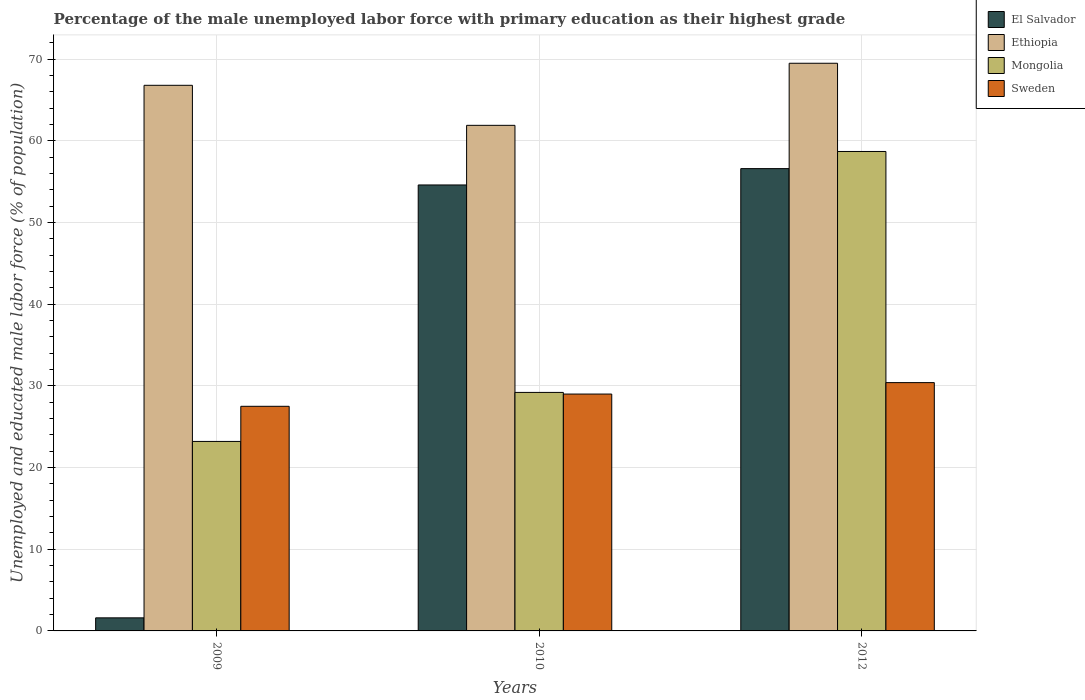How many different coloured bars are there?
Offer a very short reply. 4. Are the number of bars on each tick of the X-axis equal?
Your response must be concise. Yes. How many bars are there on the 1st tick from the left?
Offer a very short reply. 4. What is the label of the 1st group of bars from the left?
Provide a short and direct response. 2009. What is the percentage of the unemployed male labor force with primary education in El Salvador in 2010?
Give a very brief answer. 54.6. Across all years, what is the maximum percentage of the unemployed male labor force with primary education in Mongolia?
Give a very brief answer. 58.7. Across all years, what is the minimum percentage of the unemployed male labor force with primary education in Mongolia?
Provide a short and direct response. 23.2. In which year was the percentage of the unemployed male labor force with primary education in Ethiopia maximum?
Your response must be concise. 2012. In which year was the percentage of the unemployed male labor force with primary education in El Salvador minimum?
Your answer should be very brief. 2009. What is the total percentage of the unemployed male labor force with primary education in Sweden in the graph?
Ensure brevity in your answer.  86.9. What is the difference between the percentage of the unemployed male labor force with primary education in Sweden in 2010 and the percentage of the unemployed male labor force with primary education in El Salvador in 2009?
Your answer should be compact. 27.4. What is the average percentage of the unemployed male labor force with primary education in Ethiopia per year?
Your answer should be compact. 66.07. In the year 2010, what is the difference between the percentage of the unemployed male labor force with primary education in Mongolia and percentage of the unemployed male labor force with primary education in Sweden?
Provide a succinct answer. 0.2. What is the ratio of the percentage of the unemployed male labor force with primary education in Ethiopia in 2010 to that in 2012?
Your answer should be compact. 0.89. Is the percentage of the unemployed male labor force with primary education in Sweden in 2010 less than that in 2012?
Provide a short and direct response. Yes. Is the difference between the percentage of the unemployed male labor force with primary education in Mongolia in 2009 and 2012 greater than the difference between the percentage of the unemployed male labor force with primary education in Sweden in 2009 and 2012?
Your answer should be very brief. No. What is the difference between the highest and the second highest percentage of the unemployed male labor force with primary education in Mongolia?
Ensure brevity in your answer.  29.5. What is the difference between the highest and the lowest percentage of the unemployed male labor force with primary education in Mongolia?
Ensure brevity in your answer.  35.5. In how many years, is the percentage of the unemployed male labor force with primary education in Mongolia greater than the average percentage of the unemployed male labor force with primary education in Mongolia taken over all years?
Provide a succinct answer. 1. What does the 2nd bar from the left in 2010 represents?
Ensure brevity in your answer.  Ethiopia. What does the 2nd bar from the right in 2012 represents?
Provide a short and direct response. Mongolia. Is it the case that in every year, the sum of the percentage of the unemployed male labor force with primary education in Mongolia and percentage of the unemployed male labor force with primary education in El Salvador is greater than the percentage of the unemployed male labor force with primary education in Ethiopia?
Offer a very short reply. No. How many years are there in the graph?
Your answer should be compact. 3. What is the difference between two consecutive major ticks on the Y-axis?
Make the answer very short. 10. Are the values on the major ticks of Y-axis written in scientific E-notation?
Offer a very short reply. No. How are the legend labels stacked?
Ensure brevity in your answer.  Vertical. What is the title of the graph?
Make the answer very short. Percentage of the male unemployed labor force with primary education as their highest grade. Does "Luxembourg" appear as one of the legend labels in the graph?
Provide a short and direct response. No. What is the label or title of the X-axis?
Offer a terse response. Years. What is the label or title of the Y-axis?
Provide a succinct answer. Unemployed and educated male labor force (% of population). What is the Unemployed and educated male labor force (% of population) in El Salvador in 2009?
Your answer should be very brief. 1.6. What is the Unemployed and educated male labor force (% of population) of Ethiopia in 2009?
Ensure brevity in your answer.  66.8. What is the Unemployed and educated male labor force (% of population) in Mongolia in 2009?
Your answer should be compact. 23.2. What is the Unemployed and educated male labor force (% of population) in Sweden in 2009?
Give a very brief answer. 27.5. What is the Unemployed and educated male labor force (% of population) of El Salvador in 2010?
Provide a short and direct response. 54.6. What is the Unemployed and educated male labor force (% of population) in Ethiopia in 2010?
Provide a short and direct response. 61.9. What is the Unemployed and educated male labor force (% of population) in Mongolia in 2010?
Your response must be concise. 29.2. What is the Unemployed and educated male labor force (% of population) in El Salvador in 2012?
Provide a succinct answer. 56.6. What is the Unemployed and educated male labor force (% of population) of Ethiopia in 2012?
Give a very brief answer. 69.5. What is the Unemployed and educated male labor force (% of population) of Mongolia in 2012?
Your answer should be very brief. 58.7. What is the Unemployed and educated male labor force (% of population) in Sweden in 2012?
Your answer should be compact. 30.4. Across all years, what is the maximum Unemployed and educated male labor force (% of population) of El Salvador?
Make the answer very short. 56.6. Across all years, what is the maximum Unemployed and educated male labor force (% of population) of Ethiopia?
Provide a short and direct response. 69.5. Across all years, what is the maximum Unemployed and educated male labor force (% of population) of Mongolia?
Provide a succinct answer. 58.7. Across all years, what is the maximum Unemployed and educated male labor force (% of population) in Sweden?
Provide a short and direct response. 30.4. Across all years, what is the minimum Unemployed and educated male labor force (% of population) of El Salvador?
Your answer should be very brief. 1.6. Across all years, what is the minimum Unemployed and educated male labor force (% of population) in Ethiopia?
Keep it short and to the point. 61.9. Across all years, what is the minimum Unemployed and educated male labor force (% of population) of Mongolia?
Provide a succinct answer. 23.2. Across all years, what is the minimum Unemployed and educated male labor force (% of population) of Sweden?
Your response must be concise. 27.5. What is the total Unemployed and educated male labor force (% of population) of El Salvador in the graph?
Offer a terse response. 112.8. What is the total Unemployed and educated male labor force (% of population) in Ethiopia in the graph?
Provide a succinct answer. 198.2. What is the total Unemployed and educated male labor force (% of population) of Mongolia in the graph?
Your response must be concise. 111.1. What is the total Unemployed and educated male labor force (% of population) in Sweden in the graph?
Provide a short and direct response. 86.9. What is the difference between the Unemployed and educated male labor force (% of population) of El Salvador in 2009 and that in 2010?
Give a very brief answer. -53. What is the difference between the Unemployed and educated male labor force (% of population) of Sweden in 2009 and that in 2010?
Your answer should be very brief. -1.5. What is the difference between the Unemployed and educated male labor force (% of population) of El Salvador in 2009 and that in 2012?
Offer a very short reply. -55. What is the difference between the Unemployed and educated male labor force (% of population) of Ethiopia in 2009 and that in 2012?
Your answer should be compact. -2.7. What is the difference between the Unemployed and educated male labor force (% of population) of Mongolia in 2009 and that in 2012?
Provide a succinct answer. -35.5. What is the difference between the Unemployed and educated male labor force (% of population) in Ethiopia in 2010 and that in 2012?
Provide a short and direct response. -7.6. What is the difference between the Unemployed and educated male labor force (% of population) in Mongolia in 2010 and that in 2012?
Offer a very short reply. -29.5. What is the difference between the Unemployed and educated male labor force (% of population) of Sweden in 2010 and that in 2012?
Provide a succinct answer. -1.4. What is the difference between the Unemployed and educated male labor force (% of population) of El Salvador in 2009 and the Unemployed and educated male labor force (% of population) of Ethiopia in 2010?
Give a very brief answer. -60.3. What is the difference between the Unemployed and educated male labor force (% of population) of El Salvador in 2009 and the Unemployed and educated male labor force (% of population) of Mongolia in 2010?
Offer a terse response. -27.6. What is the difference between the Unemployed and educated male labor force (% of population) of El Salvador in 2009 and the Unemployed and educated male labor force (% of population) of Sweden in 2010?
Offer a terse response. -27.4. What is the difference between the Unemployed and educated male labor force (% of population) in Ethiopia in 2009 and the Unemployed and educated male labor force (% of population) in Mongolia in 2010?
Offer a very short reply. 37.6. What is the difference between the Unemployed and educated male labor force (% of population) of Ethiopia in 2009 and the Unemployed and educated male labor force (% of population) of Sweden in 2010?
Give a very brief answer. 37.8. What is the difference between the Unemployed and educated male labor force (% of population) of Mongolia in 2009 and the Unemployed and educated male labor force (% of population) of Sweden in 2010?
Provide a succinct answer. -5.8. What is the difference between the Unemployed and educated male labor force (% of population) in El Salvador in 2009 and the Unemployed and educated male labor force (% of population) in Ethiopia in 2012?
Make the answer very short. -67.9. What is the difference between the Unemployed and educated male labor force (% of population) of El Salvador in 2009 and the Unemployed and educated male labor force (% of population) of Mongolia in 2012?
Your answer should be very brief. -57.1. What is the difference between the Unemployed and educated male labor force (% of population) in El Salvador in 2009 and the Unemployed and educated male labor force (% of population) in Sweden in 2012?
Offer a very short reply. -28.8. What is the difference between the Unemployed and educated male labor force (% of population) in Ethiopia in 2009 and the Unemployed and educated male labor force (% of population) in Sweden in 2012?
Your answer should be compact. 36.4. What is the difference between the Unemployed and educated male labor force (% of population) of El Salvador in 2010 and the Unemployed and educated male labor force (% of population) of Ethiopia in 2012?
Your response must be concise. -14.9. What is the difference between the Unemployed and educated male labor force (% of population) in El Salvador in 2010 and the Unemployed and educated male labor force (% of population) in Mongolia in 2012?
Your answer should be very brief. -4.1. What is the difference between the Unemployed and educated male labor force (% of population) of El Salvador in 2010 and the Unemployed and educated male labor force (% of population) of Sweden in 2012?
Offer a terse response. 24.2. What is the difference between the Unemployed and educated male labor force (% of population) in Ethiopia in 2010 and the Unemployed and educated male labor force (% of population) in Sweden in 2012?
Provide a short and direct response. 31.5. What is the difference between the Unemployed and educated male labor force (% of population) in Mongolia in 2010 and the Unemployed and educated male labor force (% of population) in Sweden in 2012?
Give a very brief answer. -1.2. What is the average Unemployed and educated male labor force (% of population) in El Salvador per year?
Make the answer very short. 37.6. What is the average Unemployed and educated male labor force (% of population) of Ethiopia per year?
Keep it short and to the point. 66.07. What is the average Unemployed and educated male labor force (% of population) in Mongolia per year?
Your response must be concise. 37.03. What is the average Unemployed and educated male labor force (% of population) in Sweden per year?
Your answer should be compact. 28.97. In the year 2009, what is the difference between the Unemployed and educated male labor force (% of population) in El Salvador and Unemployed and educated male labor force (% of population) in Ethiopia?
Give a very brief answer. -65.2. In the year 2009, what is the difference between the Unemployed and educated male labor force (% of population) of El Salvador and Unemployed and educated male labor force (% of population) of Mongolia?
Offer a terse response. -21.6. In the year 2009, what is the difference between the Unemployed and educated male labor force (% of population) in El Salvador and Unemployed and educated male labor force (% of population) in Sweden?
Make the answer very short. -25.9. In the year 2009, what is the difference between the Unemployed and educated male labor force (% of population) in Ethiopia and Unemployed and educated male labor force (% of population) in Mongolia?
Offer a very short reply. 43.6. In the year 2009, what is the difference between the Unemployed and educated male labor force (% of population) of Ethiopia and Unemployed and educated male labor force (% of population) of Sweden?
Give a very brief answer. 39.3. In the year 2009, what is the difference between the Unemployed and educated male labor force (% of population) of Mongolia and Unemployed and educated male labor force (% of population) of Sweden?
Provide a succinct answer. -4.3. In the year 2010, what is the difference between the Unemployed and educated male labor force (% of population) of El Salvador and Unemployed and educated male labor force (% of population) of Mongolia?
Ensure brevity in your answer.  25.4. In the year 2010, what is the difference between the Unemployed and educated male labor force (% of population) of El Salvador and Unemployed and educated male labor force (% of population) of Sweden?
Provide a short and direct response. 25.6. In the year 2010, what is the difference between the Unemployed and educated male labor force (% of population) of Ethiopia and Unemployed and educated male labor force (% of population) of Mongolia?
Ensure brevity in your answer.  32.7. In the year 2010, what is the difference between the Unemployed and educated male labor force (% of population) of Ethiopia and Unemployed and educated male labor force (% of population) of Sweden?
Your answer should be very brief. 32.9. In the year 2012, what is the difference between the Unemployed and educated male labor force (% of population) of El Salvador and Unemployed and educated male labor force (% of population) of Ethiopia?
Give a very brief answer. -12.9. In the year 2012, what is the difference between the Unemployed and educated male labor force (% of population) in El Salvador and Unemployed and educated male labor force (% of population) in Sweden?
Provide a succinct answer. 26.2. In the year 2012, what is the difference between the Unemployed and educated male labor force (% of population) of Ethiopia and Unemployed and educated male labor force (% of population) of Mongolia?
Your answer should be very brief. 10.8. In the year 2012, what is the difference between the Unemployed and educated male labor force (% of population) of Ethiopia and Unemployed and educated male labor force (% of population) of Sweden?
Your answer should be very brief. 39.1. In the year 2012, what is the difference between the Unemployed and educated male labor force (% of population) in Mongolia and Unemployed and educated male labor force (% of population) in Sweden?
Give a very brief answer. 28.3. What is the ratio of the Unemployed and educated male labor force (% of population) of El Salvador in 2009 to that in 2010?
Make the answer very short. 0.03. What is the ratio of the Unemployed and educated male labor force (% of population) in Ethiopia in 2009 to that in 2010?
Ensure brevity in your answer.  1.08. What is the ratio of the Unemployed and educated male labor force (% of population) in Mongolia in 2009 to that in 2010?
Offer a very short reply. 0.79. What is the ratio of the Unemployed and educated male labor force (% of population) in Sweden in 2009 to that in 2010?
Your answer should be very brief. 0.95. What is the ratio of the Unemployed and educated male labor force (% of population) of El Salvador in 2009 to that in 2012?
Your answer should be compact. 0.03. What is the ratio of the Unemployed and educated male labor force (% of population) of Ethiopia in 2009 to that in 2012?
Keep it short and to the point. 0.96. What is the ratio of the Unemployed and educated male labor force (% of population) in Mongolia in 2009 to that in 2012?
Your response must be concise. 0.4. What is the ratio of the Unemployed and educated male labor force (% of population) of Sweden in 2009 to that in 2012?
Provide a succinct answer. 0.9. What is the ratio of the Unemployed and educated male labor force (% of population) of El Salvador in 2010 to that in 2012?
Make the answer very short. 0.96. What is the ratio of the Unemployed and educated male labor force (% of population) of Ethiopia in 2010 to that in 2012?
Offer a terse response. 0.89. What is the ratio of the Unemployed and educated male labor force (% of population) of Mongolia in 2010 to that in 2012?
Ensure brevity in your answer.  0.5. What is the ratio of the Unemployed and educated male labor force (% of population) of Sweden in 2010 to that in 2012?
Your response must be concise. 0.95. What is the difference between the highest and the second highest Unemployed and educated male labor force (% of population) in El Salvador?
Make the answer very short. 2. What is the difference between the highest and the second highest Unemployed and educated male labor force (% of population) in Mongolia?
Ensure brevity in your answer.  29.5. What is the difference between the highest and the second highest Unemployed and educated male labor force (% of population) of Sweden?
Provide a short and direct response. 1.4. What is the difference between the highest and the lowest Unemployed and educated male labor force (% of population) in El Salvador?
Provide a short and direct response. 55. What is the difference between the highest and the lowest Unemployed and educated male labor force (% of population) of Ethiopia?
Your response must be concise. 7.6. What is the difference between the highest and the lowest Unemployed and educated male labor force (% of population) in Mongolia?
Give a very brief answer. 35.5. What is the difference between the highest and the lowest Unemployed and educated male labor force (% of population) in Sweden?
Provide a succinct answer. 2.9. 